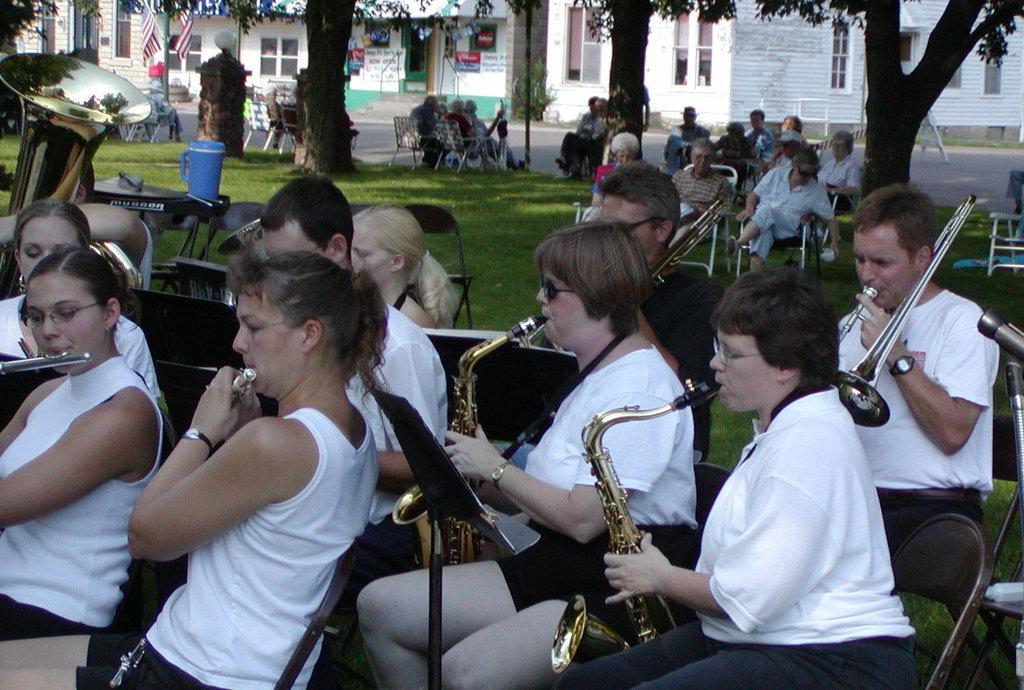Can you describe this image briefly? In this picture, we see people sitting on the chairs are playing flutes, saxophones and trumpets. Behind them, we see people sitting on the chairs and holding musical instruments in their hands. Beside them, we see a garbage bin in blue color. In the background, we see buildings and trees. In the left top of the picture, we see a flag in red, white and blue color. 